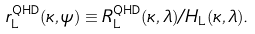Convert formula to latex. <formula><loc_0><loc_0><loc_500><loc_500>r ^ { \text {QHD} } _ { \text  L} (\kappa,\psi)\equiv  R^{\text {QHD} } _ { \text  L} (\kappa, \lambda)/H_{\text  L} (\kappa, \lambda) .</formula> 